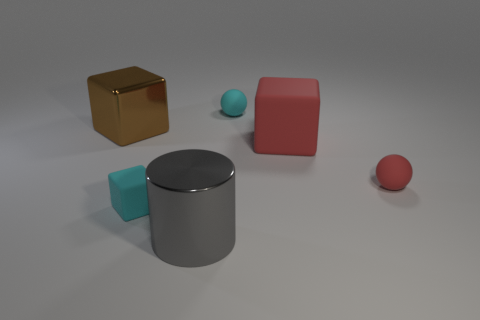Subtract all tiny cyan cubes. How many cubes are left? 2 Add 3 small cyan matte cubes. How many objects exist? 9 Subtract all red spheres. How many spheres are left? 1 Subtract 0 purple cylinders. How many objects are left? 6 Subtract all cylinders. How many objects are left? 5 Subtract 1 spheres. How many spheres are left? 1 Subtract all cyan spheres. Subtract all yellow cylinders. How many spheres are left? 1 Subtract all gray spheres. Subtract all large gray cylinders. How many objects are left? 5 Add 1 brown objects. How many brown objects are left? 2 Add 2 red spheres. How many red spheres exist? 3 